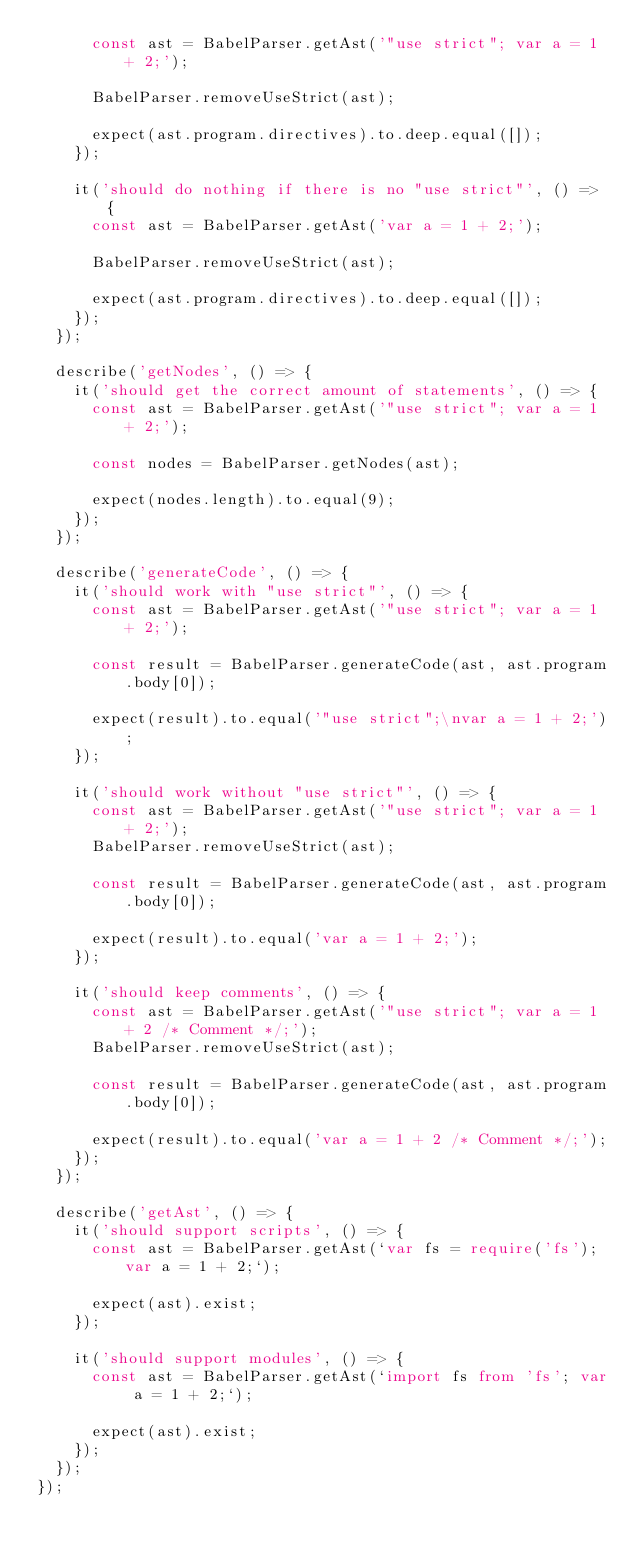<code> <loc_0><loc_0><loc_500><loc_500><_TypeScript_>      const ast = BabelParser.getAst('"use strict"; var a = 1 + 2;');

      BabelParser.removeUseStrict(ast);

      expect(ast.program.directives).to.deep.equal([]);
    });

    it('should do nothing if there is no "use strict"', () => {
      const ast = BabelParser.getAst('var a = 1 + 2;');

      BabelParser.removeUseStrict(ast);

      expect(ast.program.directives).to.deep.equal([]);
    });
  });

  describe('getNodes', () => {
    it('should get the correct amount of statements', () => {
      const ast = BabelParser.getAst('"use strict"; var a = 1 + 2;');

      const nodes = BabelParser.getNodes(ast);

      expect(nodes.length).to.equal(9);
    });
  });

  describe('generateCode', () => {
    it('should work with "use strict"', () => {
      const ast = BabelParser.getAst('"use strict"; var a = 1 + 2;');

      const result = BabelParser.generateCode(ast, ast.program.body[0]);

      expect(result).to.equal('"use strict";\nvar a = 1 + 2;');
    });

    it('should work without "use strict"', () => {
      const ast = BabelParser.getAst('"use strict"; var a = 1 + 2;');
      BabelParser.removeUseStrict(ast);

      const result = BabelParser.generateCode(ast, ast.program.body[0]);

      expect(result).to.equal('var a = 1 + 2;');
    });

    it('should keep comments', () => {
      const ast = BabelParser.getAst('"use strict"; var a = 1 + 2 /* Comment */;');
      BabelParser.removeUseStrict(ast);

      const result = BabelParser.generateCode(ast, ast.program.body[0]);

      expect(result).to.equal('var a = 1 + 2 /* Comment */;');
    });
  });

  describe('getAst', () => {
    it('should support scripts', () => {
      const ast = BabelParser.getAst(`var fs = require('fs'); var a = 1 + 2;`);

      expect(ast).exist;
    });

    it('should support modules', () => {
      const ast = BabelParser.getAst(`import fs from 'fs'; var a = 1 + 2;`);

      expect(ast).exist;
    });
  });
});
</code> 